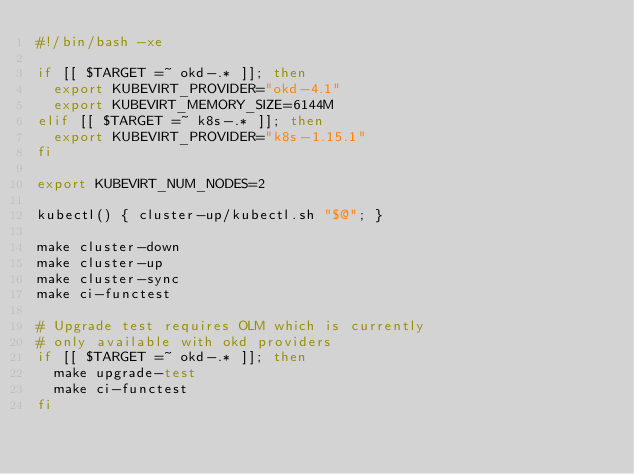<code> <loc_0><loc_0><loc_500><loc_500><_Bash_>#!/bin/bash -xe

if [[ $TARGET =~ okd-.* ]]; then
  export KUBEVIRT_PROVIDER="okd-4.1"
  export KUBEVIRT_MEMORY_SIZE=6144M
elif [[ $TARGET =~ k8s-.* ]]; then
  export KUBEVIRT_PROVIDER="k8s-1.15.1"
fi

export KUBEVIRT_NUM_NODES=2

kubectl() { cluster-up/kubectl.sh "$@"; }

make cluster-down
make cluster-up
make cluster-sync
make ci-functest

# Upgrade test requires OLM which is currently
# only available with okd providers
if [[ $TARGET =~ okd-.* ]]; then
  make upgrade-test
  make ci-functest
fi
</code> 